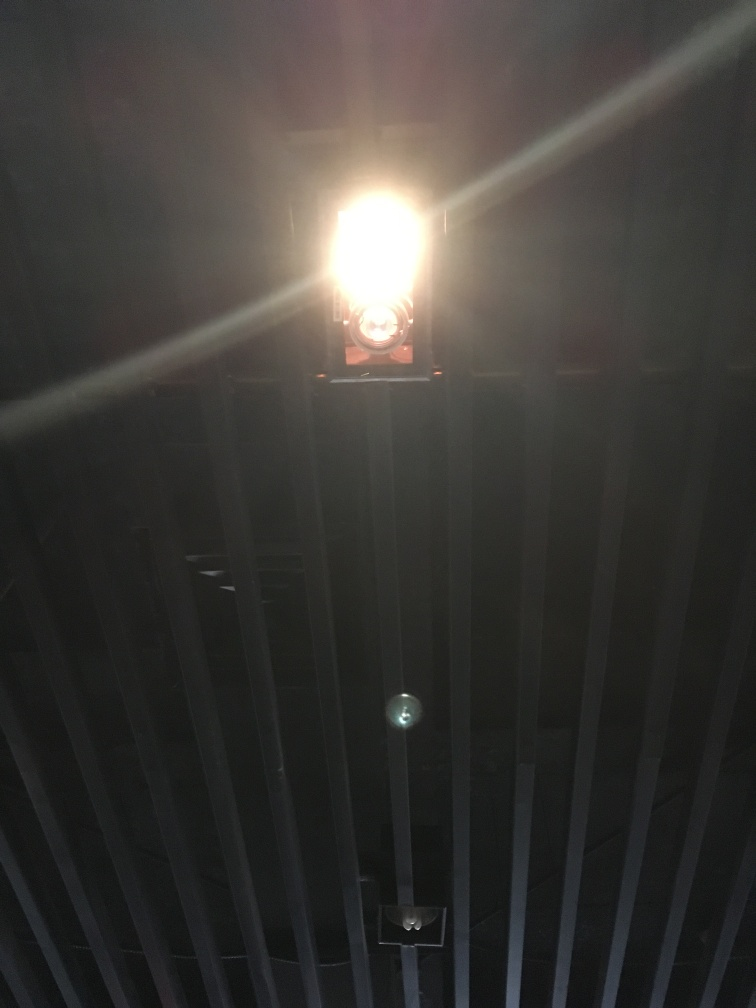Is the composition well-balanced? While the response selected 'No,' the question of balance in composition is subjective. From a technical perspective, the strong backlight creates a silhouette effect that may seem unbalanced to some. However, one could argue that the interplay of light and shadow, as well as the central positioning of the light source, could convey a form of symmetry and purposeful contrast. The starkness and the gradation of light might be interpreted as an intentional artistic choice, lending a certain drama to the image. So, the composition can be seen as well-balanced depending on the intended effect. 